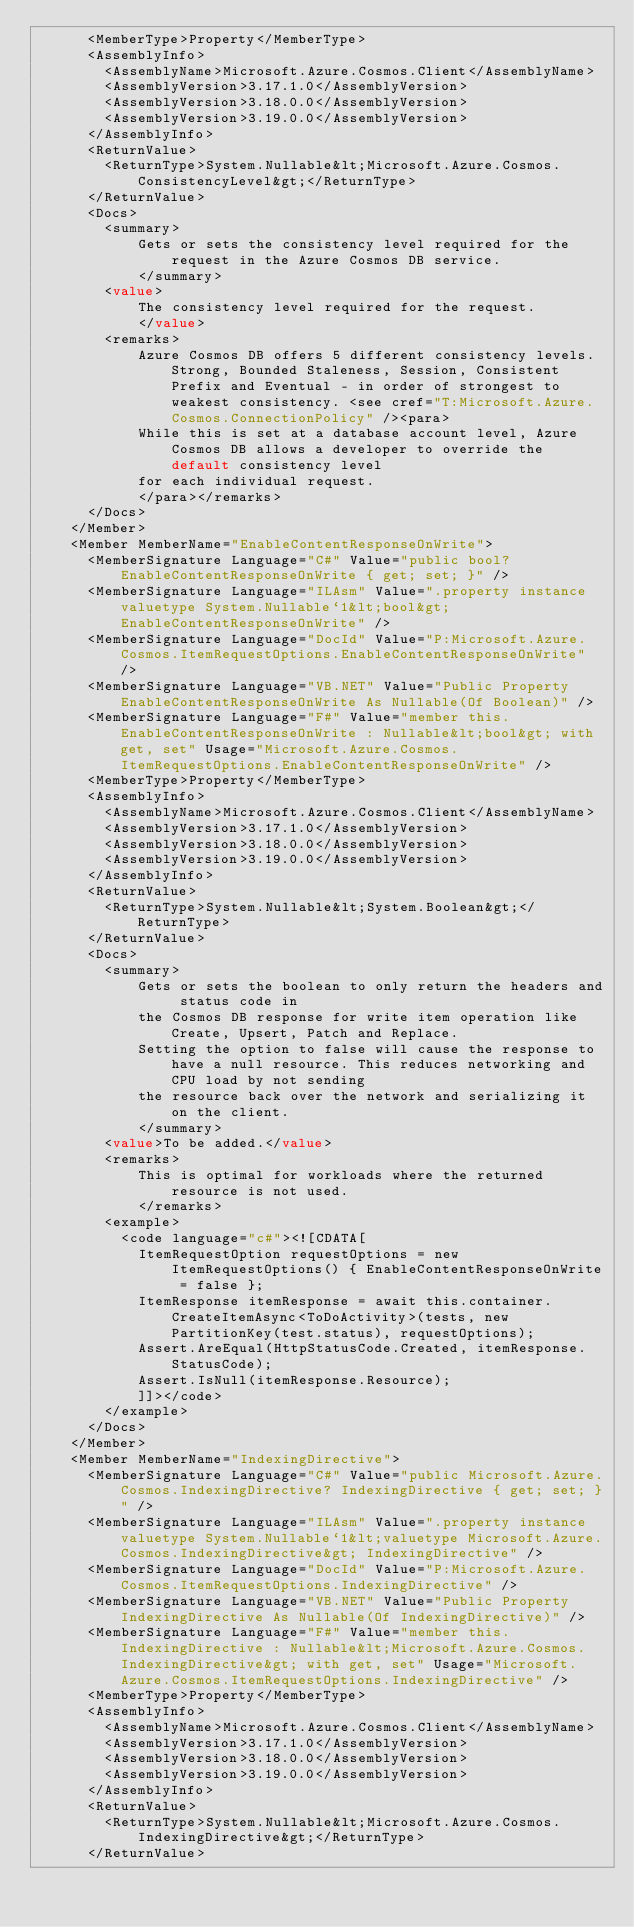Convert code to text. <code><loc_0><loc_0><loc_500><loc_500><_XML_>      <MemberType>Property</MemberType>
      <AssemblyInfo>
        <AssemblyName>Microsoft.Azure.Cosmos.Client</AssemblyName>
        <AssemblyVersion>3.17.1.0</AssemblyVersion>
        <AssemblyVersion>3.18.0.0</AssemblyVersion>
        <AssemblyVersion>3.19.0.0</AssemblyVersion>
      </AssemblyInfo>
      <ReturnValue>
        <ReturnType>System.Nullable&lt;Microsoft.Azure.Cosmos.ConsistencyLevel&gt;</ReturnType>
      </ReturnValue>
      <Docs>
        <summary>
            Gets or sets the consistency level required for the request in the Azure Cosmos DB service.
            </summary>
        <value>
            The consistency level required for the request.
            </value>
        <remarks>
            Azure Cosmos DB offers 5 different consistency levels. Strong, Bounded Staleness, Session, Consistent Prefix and Eventual - in order of strongest to weakest consistency. <see cref="T:Microsoft.Azure.Cosmos.ConnectionPolicy" /><para>
            While this is set at a database account level, Azure Cosmos DB allows a developer to override the default consistency level
            for each individual request.
            </para></remarks>
      </Docs>
    </Member>
    <Member MemberName="EnableContentResponseOnWrite">
      <MemberSignature Language="C#" Value="public bool? EnableContentResponseOnWrite { get; set; }" />
      <MemberSignature Language="ILAsm" Value=".property instance valuetype System.Nullable`1&lt;bool&gt; EnableContentResponseOnWrite" />
      <MemberSignature Language="DocId" Value="P:Microsoft.Azure.Cosmos.ItemRequestOptions.EnableContentResponseOnWrite" />
      <MemberSignature Language="VB.NET" Value="Public Property EnableContentResponseOnWrite As Nullable(Of Boolean)" />
      <MemberSignature Language="F#" Value="member this.EnableContentResponseOnWrite : Nullable&lt;bool&gt; with get, set" Usage="Microsoft.Azure.Cosmos.ItemRequestOptions.EnableContentResponseOnWrite" />
      <MemberType>Property</MemberType>
      <AssemblyInfo>
        <AssemblyName>Microsoft.Azure.Cosmos.Client</AssemblyName>
        <AssemblyVersion>3.17.1.0</AssemblyVersion>
        <AssemblyVersion>3.18.0.0</AssemblyVersion>
        <AssemblyVersion>3.19.0.0</AssemblyVersion>
      </AssemblyInfo>
      <ReturnValue>
        <ReturnType>System.Nullable&lt;System.Boolean&gt;</ReturnType>
      </ReturnValue>
      <Docs>
        <summary>
            Gets or sets the boolean to only return the headers and status code in
            the Cosmos DB response for write item operation like Create, Upsert, Patch and Replace.
            Setting the option to false will cause the response to have a null resource. This reduces networking and CPU load by not sending
            the resource back over the network and serializing it on the client.
            </summary>
        <value>To be added.</value>
        <remarks>
            This is optimal for workloads where the returned resource is not used.
            </remarks>
        <example>
          <code language="c#"><![CDATA[
            ItemRequestOption requestOptions = new ItemRequestOptions() { EnableContentResponseOnWrite = false };
            ItemResponse itemResponse = await this.container.CreateItemAsync<ToDoActivity>(tests, new PartitionKey(test.status), requestOptions);
            Assert.AreEqual(HttpStatusCode.Created, itemResponse.StatusCode);
            Assert.IsNull(itemResponse.Resource);
            ]]></code>
        </example>
      </Docs>
    </Member>
    <Member MemberName="IndexingDirective">
      <MemberSignature Language="C#" Value="public Microsoft.Azure.Cosmos.IndexingDirective? IndexingDirective { get; set; }" />
      <MemberSignature Language="ILAsm" Value=".property instance valuetype System.Nullable`1&lt;valuetype Microsoft.Azure.Cosmos.IndexingDirective&gt; IndexingDirective" />
      <MemberSignature Language="DocId" Value="P:Microsoft.Azure.Cosmos.ItemRequestOptions.IndexingDirective" />
      <MemberSignature Language="VB.NET" Value="Public Property IndexingDirective As Nullable(Of IndexingDirective)" />
      <MemberSignature Language="F#" Value="member this.IndexingDirective : Nullable&lt;Microsoft.Azure.Cosmos.IndexingDirective&gt; with get, set" Usage="Microsoft.Azure.Cosmos.ItemRequestOptions.IndexingDirective" />
      <MemberType>Property</MemberType>
      <AssemblyInfo>
        <AssemblyName>Microsoft.Azure.Cosmos.Client</AssemblyName>
        <AssemblyVersion>3.17.1.0</AssemblyVersion>
        <AssemblyVersion>3.18.0.0</AssemblyVersion>
        <AssemblyVersion>3.19.0.0</AssemblyVersion>
      </AssemblyInfo>
      <ReturnValue>
        <ReturnType>System.Nullable&lt;Microsoft.Azure.Cosmos.IndexingDirective&gt;</ReturnType>
      </ReturnValue></code> 